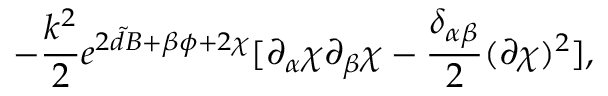Convert formula to latex. <formula><loc_0><loc_0><loc_500><loc_500>- \frac { k ^ { 2 } } { 2 } e ^ { 2 { \tilde { d } } B + \beta \phi + 2 \chi } [ \partial _ { \alpha } \chi \partial _ { \beta } \chi - \frac { \delta _ { \alpha \beta } } { 2 } ( \partial \chi ) ^ { 2 } ] ,</formula> 